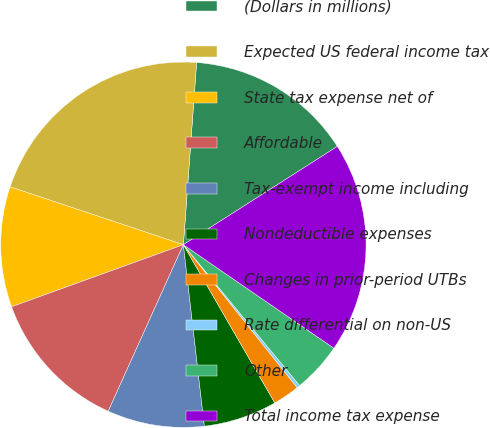Convert chart. <chart><loc_0><loc_0><loc_500><loc_500><pie_chart><fcel>(Dollars in millions)<fcel>Expected US federal income tax<fcel>State tax expense net of<fcel>Affordable<fcel>Tax-exempt income including<fcel>Nondeductible expenses<fcel>Changes in prior-period UTBs<fcel>Rate differential on non-US<fcel>Other<fcel>Total income tax expense<nl><fcel>14.8%<fcel>21.02%<fcel>10.65%<fcel>12.73%<fcel>8.58%<fcel>6.51%<fcel>2.36%<fcel>0.28%<fcel>4.43%<fcel>18.63%<nl></chart> 